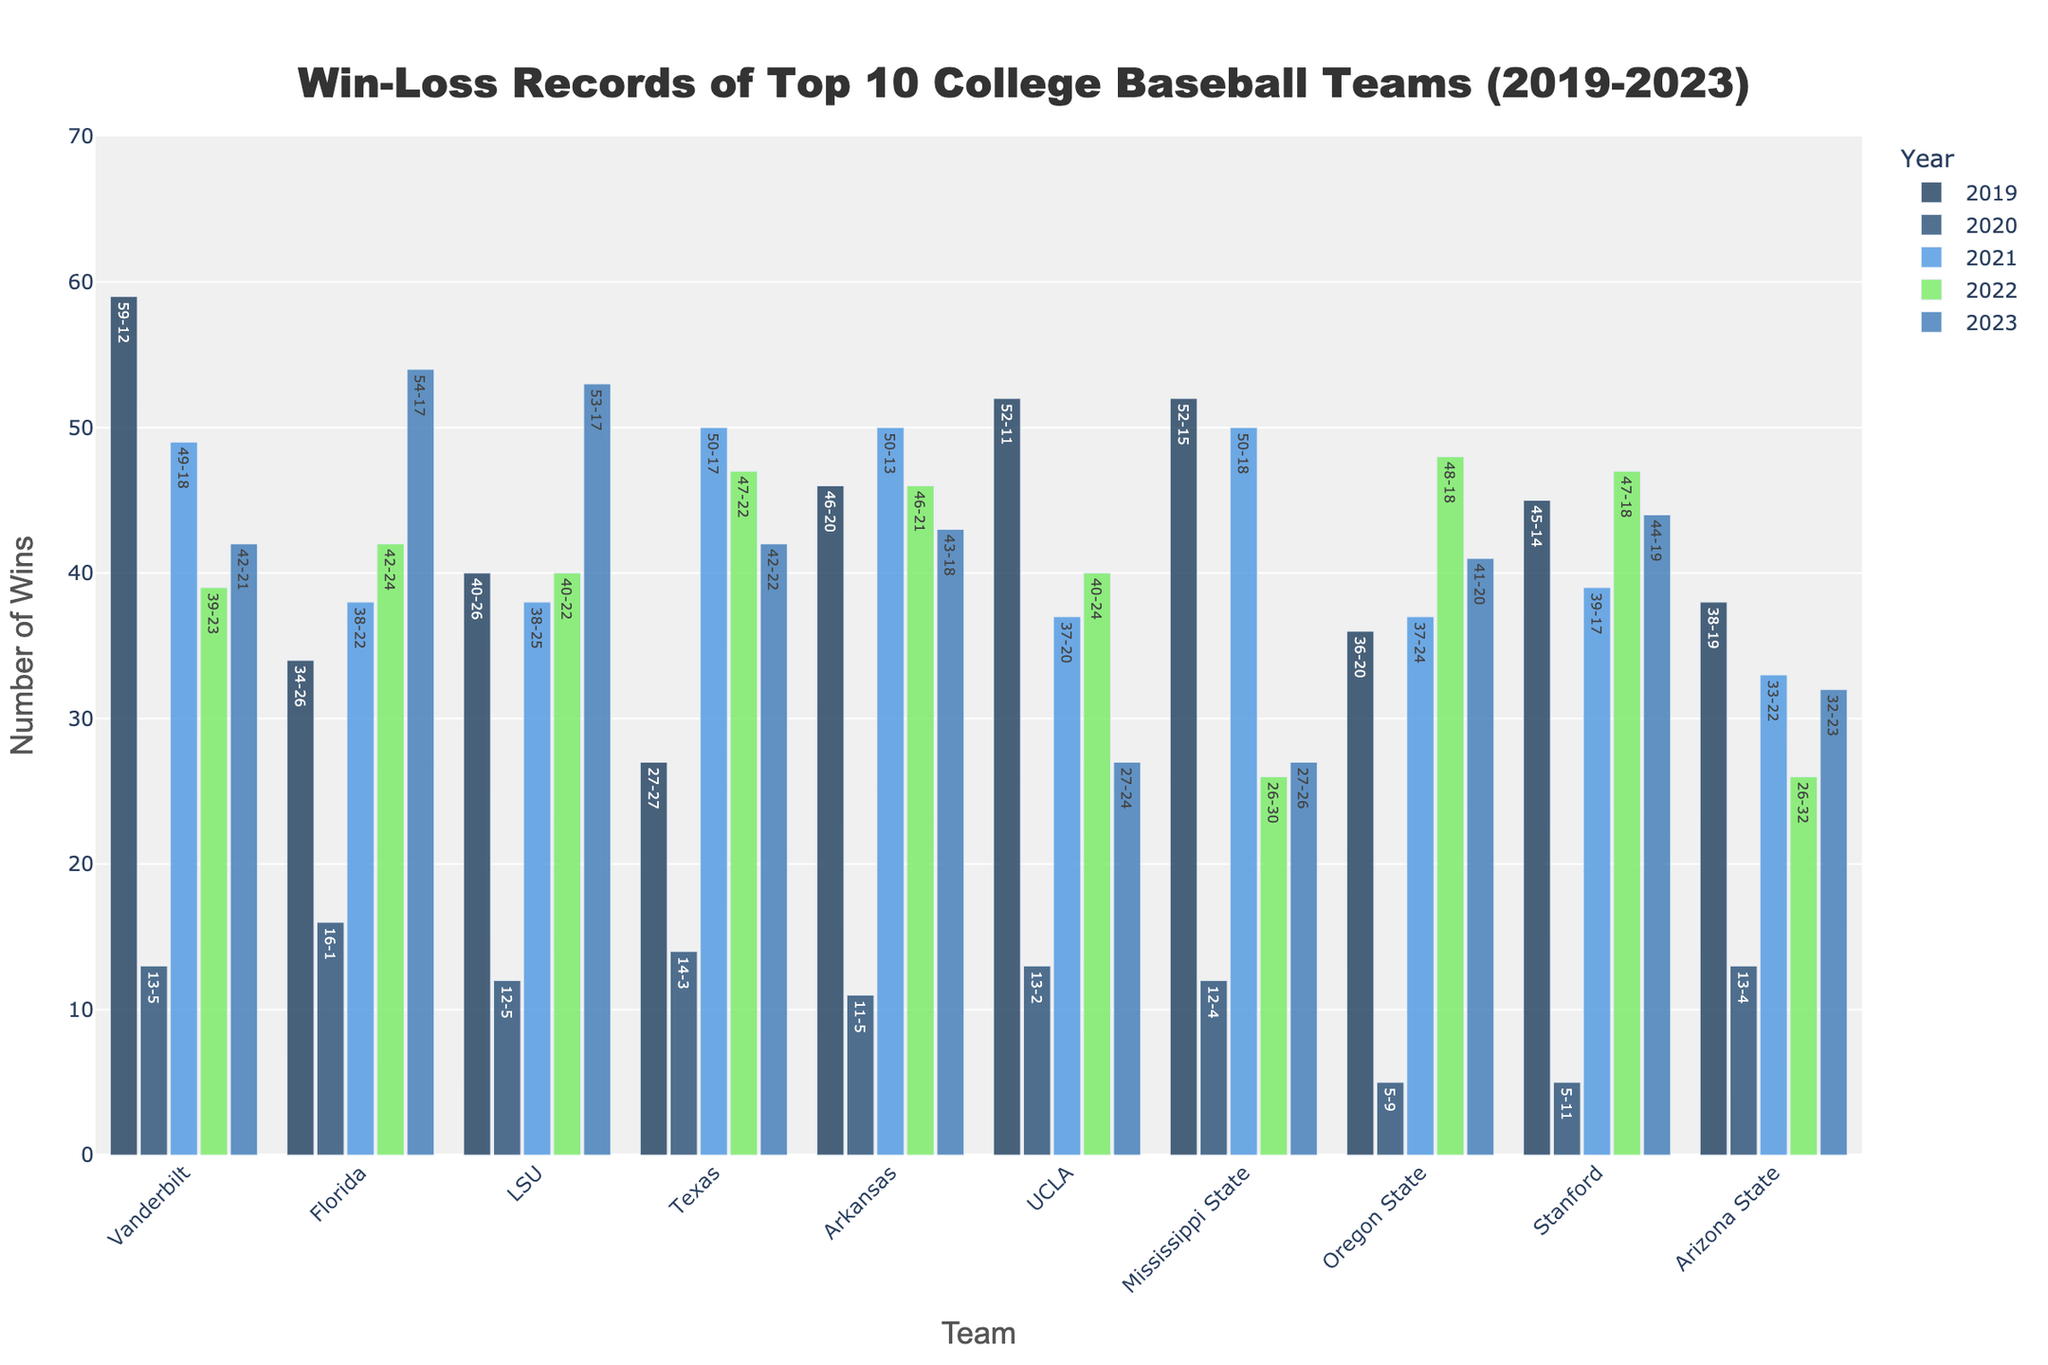Which team had the most wins in 2023? To find the team with the most wins in 2023, we check the height of the bars or the values labeled on the bars for the year 2023. Among them, Florida and LSU both have bars labeled with 54 and 53 wins respectively, with Florida having 54 wins.
Answer: Florida Between 2019 and 2023, which team’s win-loss record remained most consistent in terms of win count? To determine consistency, we look at the heights of the bars for each team over the years and see which team has the least variance in win counts. Stanford shows a relatively consistent win count compared to other teams, with a range of 39-47 wins.
Answer: Stanford In which year did UCLA have the fewest wins and what was their win-loss record? By referring to the bars representing UCLA's win counts from 2019 to 2023, the shortest bar with the lowest value is in 2023. UCLA's win-loss record in 2023 is labeled on the bar as 27-24-1.
Answer: 2023, 27-24-1 Which team had the biggest improvement in wins from 2022 to 2023? To identify the biggest improvement, calculate the difference in win counts for each team between 2022 and 2023. LSU shows a noticeable improvement from 40 to 53 wins, a difference of 13 wins.
Answer: LSU Which team had the most losses in 2022? To find the team with the most losses, look at the loss values labeled on the bars for each team in 2022. Mississippi State has the most losses with 30 in 2022.
Answer: Mississippi State How many wins did Arkansas have on average per year from 2019 to 2023? To calculate Arkansas's average win count, sum their wins from 2019 to 2023 and divide by 5. The win counts are 46, 11, 50, 46, 43 respectively. The sum is 196, so the average is 196/5 = 39.2.
Answer: 39.2 Which team has the highest total number of wins over the 5-year period? By summing the win counts for each team across all years from 2019 to 2023, Vanderbilt's total win counts are 59, 13, 49, 39, and 42. Their total is 202 wins, which is higher than the totals for other teams.
Answer: Vanderbilt Which two teams had the closest win records in 2019 and what were their win counts? To find the closest win records, compare the win counts for each team in 2019. Texas and Oregon State have close win records of 27 and 36 respectively, a difference of 9 wins.
Answer: Texas and Oregon State What is the difference in the total number of losses between UCLA and Arizona State over the 5-year period? Sum the losses for UCLA (2019: 11, 2020: 2, 2021: 20, 2022: 24, 2023: 24) and Arizona State (2019: 19, 2020: 4, 2021: 22, 2022: 32, 2023: 23). The total for UCLA is 81, and for Arizona State is 100. The difference is 100 - 81 = 19.
Answer: 19 